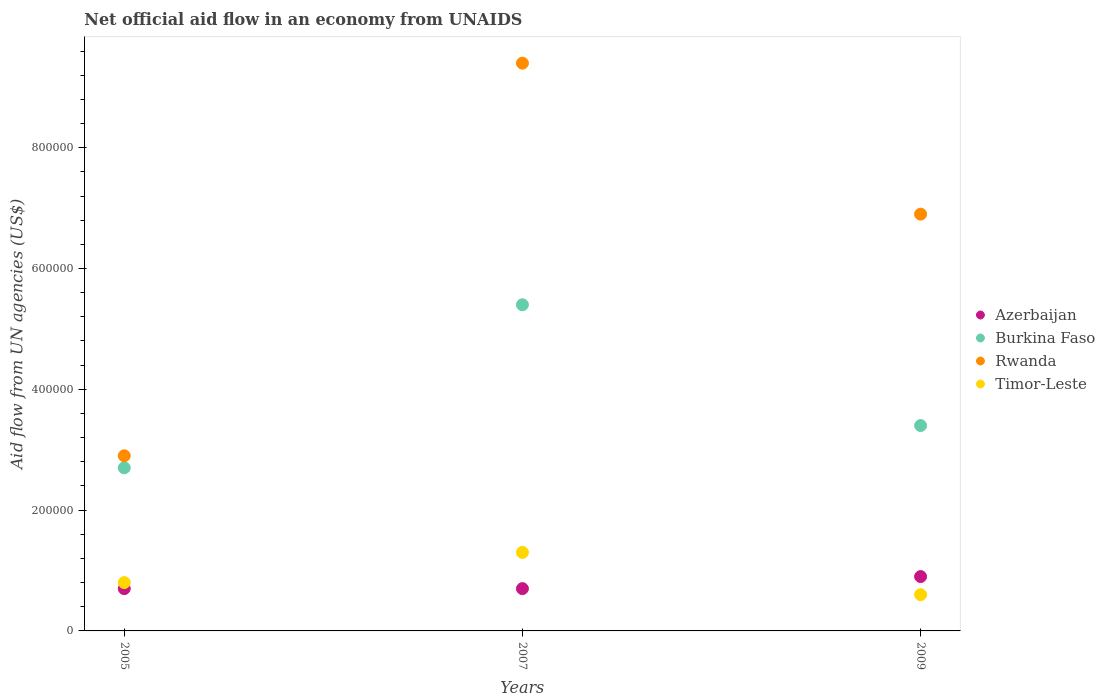How many different coloured dotlines are there?
Give a very brief answer. 4. Is the number of dotlines equal to the number of legend labels?
Your response must be concise. Yes. Across all years, what is the maximum net official aid flow in Rwanda?
Ensure brevity in your answer.  9.40e+05. In which year was the net official aid flow in Azerbaijan minimum?
Your answer should be compact. 2005. What is the total net official aid flow in Timor-Leste in the graph?
Your response must be concise. 2.70e+05. What is the difference between the net official aid flow in Burkina Faso in 2005 and that in 2009?
Provide a short and direct response. -7.00e+04. What is the difference between the net official aid flow in Timor-Leste in 2005 and the net official aid flow in Rwanda in 2009?
Offer a very short reply. -6.10e+05. What is the average net official aid flow in Rwanda per year?
Your response must be concise. 6.40e+05. In the year 2005, what is the difference between the net official aid flow in Rwanda and net official aid flow in Azerbaijan?
Your response must be concise. 2.20e+05. What is the ratio of the net official aid flow in Timor-Leste in 2005 to that in 2009?
Provide a succinct answer. 1.33. Is the net official aid flow in Rwanda in 2005 less than that in 2009?
Make the answer very short. Yes. What is the difference between the highest and the second highest net official aid flow in Burkina Faso?
Provide a succinct answer. 2.00e+05. What is the difference between the highest and the lowest net official aid flow in Burkina Faso?
Ensure brevity in your answer.  2.70e+05. In how many years, is the net official aid flow in Burkina Faso greater than the average net official aid flow in Burkina Faso taken over all years?
Provide a succinct answer. 1. Is it the case that in every year, the sum of the net official aid flow in Rwanda and net official aid flow in Burkina Faso  is greater than the sum of net official aid flow in Timor-Leste and net official aid flow in Azerbaijan?
Keep it short and to the point. Yes. Is it the case that in every year, the sum of the net official aid flow in Rwanda and net official aid flow in Timor-Leste  is greater than the net official aid flow in Azerbaijan?
Keep it short and to the point. Yes. How many dotlines are there?
Keep it short and to the point. 4. How are the legend labels stacked?
Offer a very short reply. Vertical. What is the title of the graph?
Provide a succinct answer. Net official aid flow in an economy from UNAIDS. Does "Austria" appear as one of the legend labels in the graph?
Provide a short and direct response. No. What is the label or title of the Y-axis?
Your answer should be compact. Aid flow from UN agencies (US$). What is the Aid flow from UN agencies (US$) of Burkina Faso in 2005?
Offer a terse response. 2.70e+05. What is the Aid flow from UN agencies (US$) of Burkina Faso in 2007?
Keep it short and to the point. 5.40e+05. What is the Aid flow from UN agencies (US$) of Rwanda in 2007?
Your answer should be compact. 9.40e+05. What is the Aid flow from UN agencies (US$) in Azerbaijan in 2009?
Offer a terse response. 9.00e+04. What is the Aid flow from UN agencies (US$) in Rwanda in 2009?
Keep it short and to the point. 6.90e+05. What is the Aid flow from UN agencies (US$) of Timor-Leste in 2009?
Keep it short and to the point. 6.00e+04. Across all years, what is the maximum Aid flow from UN agencies (US$) of Burkina Faso?
Ensure brevity in your answer.  5.40e+05. Across all years, what is the maximum Aid flow from UN agencies (US$) in Rwanda?
Provide a succinct answer. 9.40e+05. Across all years, what is the maximum Aid flow from UN agencies (US$) of Timor-Leste?
Keep it short and to the point. 1.30e+05. Across all years, what is the minimum Aid flow from UN agencies (US$) in Burkina Faso?
Ensure brevity in your answer.  2.70e+05. Across all years, what is the minimum Aid flow from UN agencies (US$) in Timor-Leste?
Your answer should be very brief. 6.00e+04. What is the total Aid flow from UN agencies (US$) in Azerbaijan in the graph?
Provide a succinct answer. 2.30e+05. What is the total Aid flow from UN agencies (US$) of Burkina Faso in the graph?
Keep it short and to the point. 1.15e+06. What is the total Aid flow from UN agencies (US$) in Rwanda in the graph?
Provide a succinct answer. 1.92e+06. What is the total Aid flow from UN agencies (US$) of Timor-Leste in the graph?
Provide a succinct answer. 2.70e+05. What is the difference between the Aid flow from UN agencies (US$) in Azerbaijan in 2005 and that in 2007?
Ensure brevity in your answer.  0. What is the difference between the Aid flow from UN agencies (US$) in Rwanda in 2005 and that in 2007?
Make the answer very short. -6.50e+05. What is the difference between the Aid flow from UN agencies (US$) in Azerbaijan in 2005 and that in 2009?
Provide a short and direct response. -2.00e+04. What is the difference between the Aid flow from UN agencies (US$) in Burkina Faso in 2005 and that in 2009?
Give a very brief answer. -7.00e+04. What is the difference between the Aid flow from UN agencies (US$) of Rwanda in 2005 and that in 2009?
Offer a very short reply. -4.00e+05. What is the difference between the Aid flow from UN agencies (US$) of Azerbaijan in 2005 and the Aid flow from UN agencies (US$) of Burkina Faso in 2007?
Provide a short and direct response. -4.70e+05. What is the difference between the Aid flow from UN agencies (US$) of Azerbaijan in 2005 and the Aid flow from UN agencies (US$) of Rwanda in 2007?
Provide a succinct answer. -8.70e+05. What is the difference between the Aid flow from UN agencies (US$) in Burkina Faso in 2005 and the Aid flow from UN agencies (US$) in Rwanda in 2007?
Provide a succinct answer. -6.70e+05. What is the difference between the Aid flow from UN agencies (US$) of Burkina Faso in 2005 and the Aid flow from UN agencies (US$) of Timor-Leste in 2007?
Offer a terse response. 1.40e+05. What is the difference between the Aid flow from UN agencies (US$) of Azerbaijan in 2005 and the Aid flow from UN agencies (US$) of Rwanda in 2009?
Provide a succinct answer. -6.20e+05. What is the difference between the Aid flow from UN agencies (US$) of Azerbaijan in 2005 and the Aid flow from UN agencies (US$) of Timor-Leste in 2009?
Keep it short and to the point. 10000. What is the difference between the Aid flow from UN agencies (US$) in Burkina Faso in 2005 and the Aid flow from UN agencies (US$) in Rwanda in 2009?
Your response must be concise. -4.20e+05. What is the difference between the Aid flow from UN agencies (US$) in Rwanda in 2005 and the Aid flow from UN agencies (US$) in Timor-Leste in 2009?
Provide a succinct answer. 2.30e+05. What is the difference between the Aid flow from UN agencies (US$) of Azerbaijan in 2007 and the Aid flow from UN agencies (US$) of Burkina Faso in 2009?
Your answer should be very brief. -2.70e+05. What is the difference between the Aid flow from UN agencies (US$) of Azerbaijan in 2007 and the Aid flow from UN agencies (US$) of Rwanda in 2009?
Provide a short and direct response. -6.20e+05. What is the difference between the Aid flow from UN agencies (US$) of Azerbaijan in 2007 and the Aid flow from UN agencies (US$) of Timor-Leste in 2009?
Your answer should be compact. 10000. What is the difference between the Aid flow from UN agencies (US$) of Burkina Faso in 2007 and the Aid flow from UN agencies (US$) of Rwanda in 2009?
Offer a terse response. -1.50e+05. What is the difference between the Aid flow from UN agencies (US$) in Rwanda in 2007 and the Aid flow from UN agencies (US$) in Timor-Leste in 2009?
Your answer should be very brief. 8.80e+05. What is the average Aid flow from UN agencies (US$) in Azerbaijan per year?
Your response must be concise. 7.67e+04. What is the average Aid flow from UN agencies (US$) of Burkina Faso per year?
Provide a succinct answer. 3.83e+05. What is the average Aid flow from UN agencies (US$) of Rwanda per year?
Make the answer very short. 6.40e+05. What is the average Aid flow from UN agencies (US$) of Timor-Leste per year?
Your answer should be very brief. 9.00e+04. In the year 2005, what is the difference between the Aid flow from UN agencies (US$) in Azerbaijan and Aid flow from UN agencies (US$) in Rwanda?
Keep it short and to the point. -2.20e+05. In the year 2005, what is the difference between the Aid flow from UN agencies (US$) in Azerbaijan and Aid flow from UN agencies (US$) in Timor-Leste?
Provide a succinct answer. -10000. In the year 2007, what is the difference between the Aid flow from UN agencies (US$) of Azerbaijan and Aid flow from UN agencies (US$) of Burkina Faso?
Keep it short and to the point. -4.70e+05. In the year 2007, what is the difference between the Aid flow from UN agencies (US$) in Azerbaijan and Aid flow from UN agencies (US$) in Rwanda?
Your answer should be very brief. -8.70e+05. In the year 2007, what is the difference between the Aid flow from UN agencies (US$) in Burkina Faso and Aid flow from UN agencies (US$) in Rwanda?
Provide a short and direct response. -4.00e+05. In the year 2007, what is the difference between the Aid flow from UN agencies (US$) in Rwanda and Aid flow from UN agencies (US$) in Timor-Leste?
Your response must be concise. 8.10e+05. In the year 2009, what is the difference between the Aid flow from UN agencies (US$) in Azerbaijan and Aid flow from UN agencies (US$) in Burkina Faso?
Offer a terse response. -2.50e+05. In the year 2009, what is the difference between the Aid flow from UN agencies (US$) of Azerbaijan and Aid flow from UN agencies (US$) of Rwanda?
Offer a very short reply. -6.00e+05. In the year 2009, what is the difference between the Aid flow from UN agencies (US$) of Burkina Faso and Aid flow from UN agencies (US$) of Rwanda?
Your response must be concise. -3.50e+05. In the year 2009, what is the difference between the Aid flow from UN agencies (US$) in Burkina Faso and Aid flow from UN agencies (US$) in Timor-Leste?
Provide a succinct answer. 2.80e+05. In the year 2009, what is the difference between the Aid flow from UN agencies (US$) in Rwanda and Aid flow from UN agencies (US$) in Timor-Leste?
Offer a very short reply. 6.30e+05. What is the ratio of the Aid flow from UN agencies (US$) of Rwanda in 2005 to that in 2007?
Make the answer very short. 0.31. What is the ratio of the Aid flow from UN agencies (US$) in Timor-Leste in 2005 to that in 2007?
Your answer should be compact. 0.62. What is the ratio of the Aid flow from UN agencies (US$) in Azerbaijan in 2005 to that in 2009?
Provide a succinct answer. 0.78. What is the ratio of the Aid flow from UN agencies (US$) of Burkina Faso in 2005 to that in 2009?
Make the answer very short. 0.79. What is the ratio of the Aid flow from UN agencies (US$) of Rwanda in 2005 to that in 2009?
Your answer should be very brief. 0.42. What is the ratio of the Aid flow from UN agencies (US$) of Azerbaijan in 2007 to that in 2009?
Your answer should be compact. 0.78. What is the ratio of the Aid flow from UN agencies (US$) in Burkina Faso in 2007 to that in 2009?
Your answer should be compact. 1.59. What is the ratio of the Aid flow from UN agencies (US$) in Rwanda in 2007 to that in 2009?
Ensure brevity in your answer.  1.36. What is the ratio of the Aid flow from UN agencies (US$) of Timor-Leste in 2007 to that in 2009?
Provide a short and direct response. 2.17. What is the difference between the highest and the second highest Aid flow from UN agencies (US$) of Burkina Faso?
Ensure brevity in your answer.  2.00e+05. What is the difference between the highest and the lowest Aid flow from UN agencies (US$) in Azerbaijan?
Your answer should be compact. 2.00e+04. What is the difference between the highest and the lowest Aid flow from UN agencies (US$) in Burkina Faso?
Your answer should be compact. 2.70e+05. What is the difference between the highest and the lowest Aid flow from UN agencies (US$) of Rwanda?
Provide a succinct answer. 6.50e+05. What is the difference between the highest and the lowest Aid flow from UN agencies (US$) of Timor-Leste?
Offer a very short reply. 7.00e+04. 